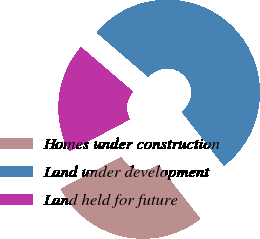<chart> <loc_0><loc_0><loc_500><loc_500><pie_chart><fcel>Homes under construction<fcel>Land under development<fcel>Land held for future<nl><fcel>27.85%<fcel>53.16%<fcel>19.0%<nl></chart> 